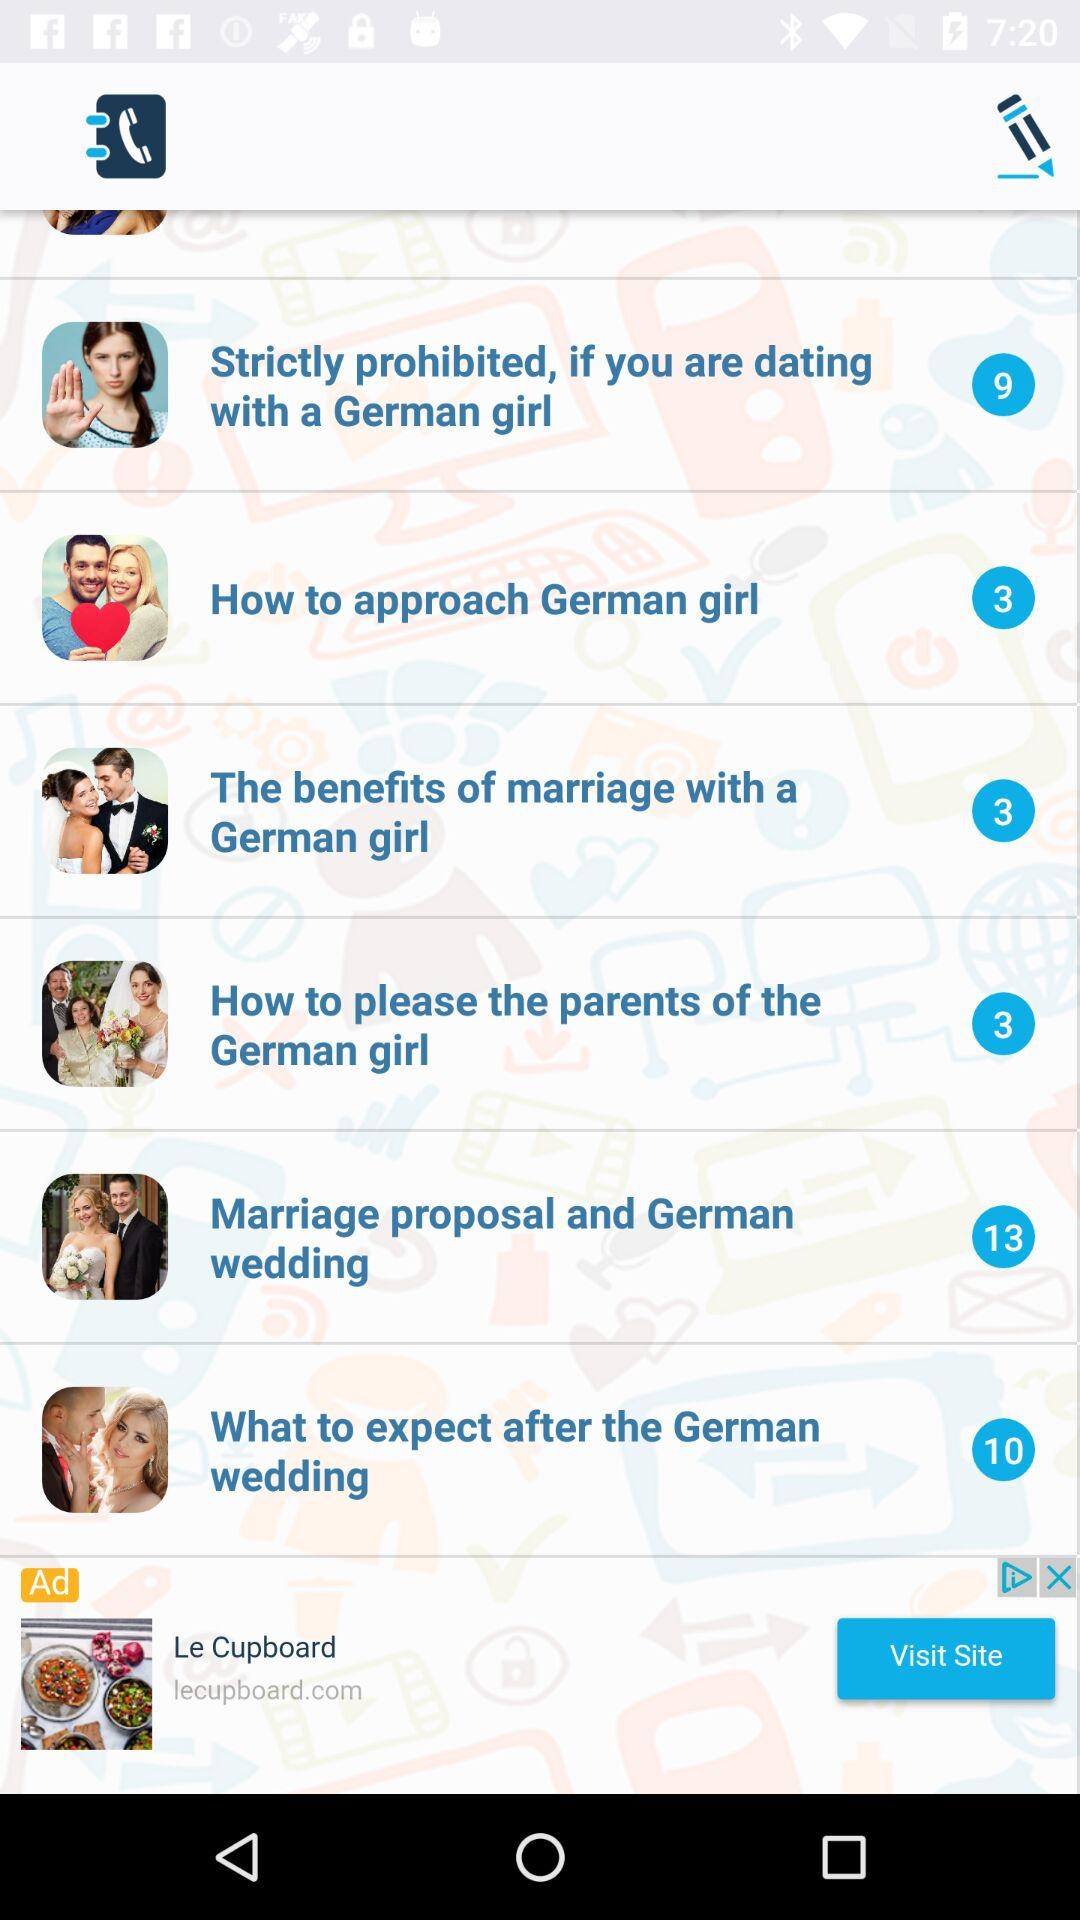What is the total number of tips on "What to expect after the German wedding"? The total number of tips is 10. 